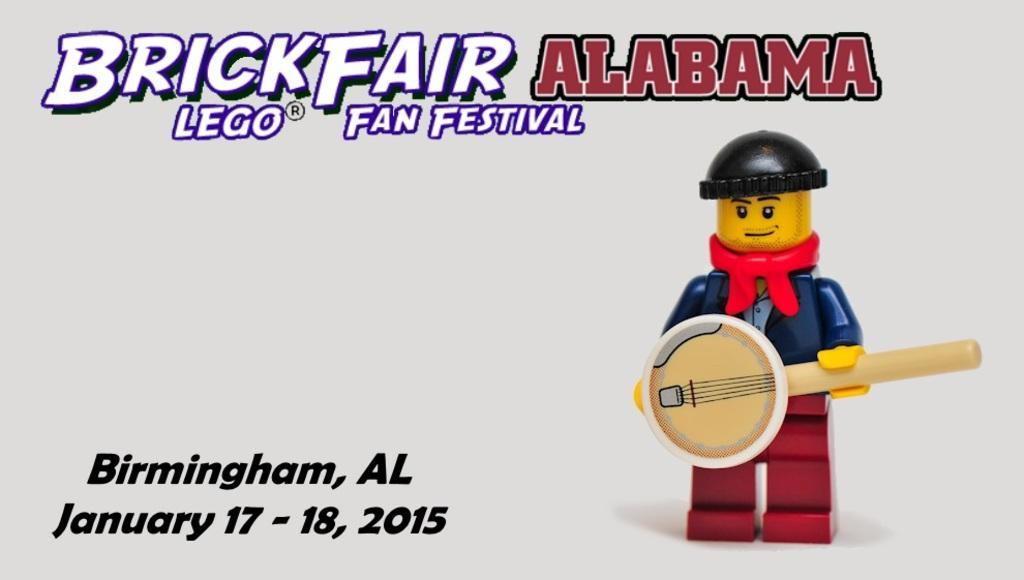How would you summarize this image in a sentence or two? In the image there is a poster. On the poster at the right side of the image there is a toy with black helmet, yellow face and blue jacket is standing and holding a musical instrument. At the top of the image there is a name of the event. And at the bottom of the image to the left side there is a name, month and date of the event. 